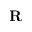<formula> <loc_0><loc_0><loc_500><loc_500>R</formula> 